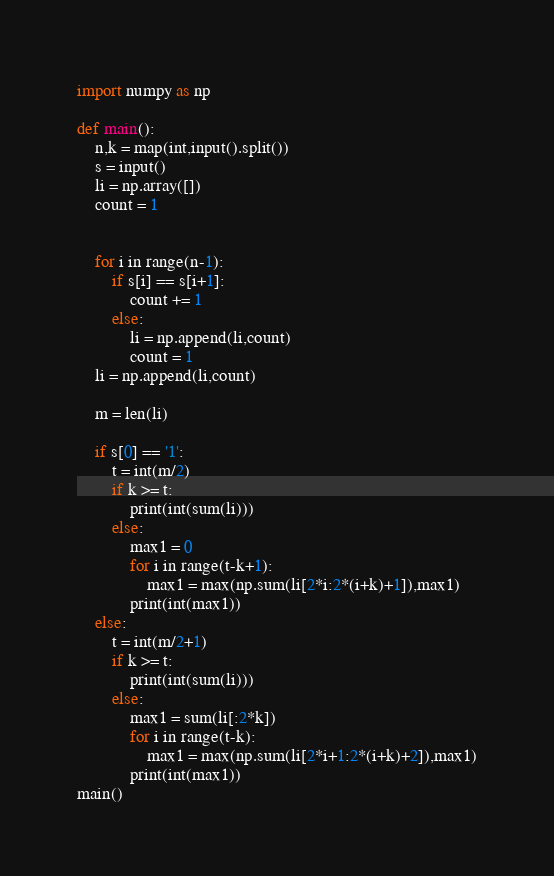<code> <loc_0><loc_0><loc_500><loc_500><_Python_>import numpy as np

def main():
    n,k = map(int,input().split())
    s = input()
    li = np.array([])
    count = 1


    for i in range(n-1):
        if s[i] == s[i+1]:
            count += 1
        else:
            li = np.append(li,count)
            count = 1
    li = np.append(li,count)

    m = len(li)

    if s[0] == '1':
        t = int(m/2)
        if k >= t:
            print(int(sum(li)))
        else:
            max1 = 0
            for i in range(t-k+1):
                max1 = max(np.sum(li[2*i:2*(i+k)+1]),max1)
            print(int(max1))
    else:
        t = int(m/2+1)
        if k >= t:
            print(int(sum(li)))
        else:
            max1 = sum(li[:2*k])
            for i in range(t-k):
                max1 = max(np.sum(li[2*i+1:2*(i+k)+2]),max1)
            print(int(max1))
main()
</code> 